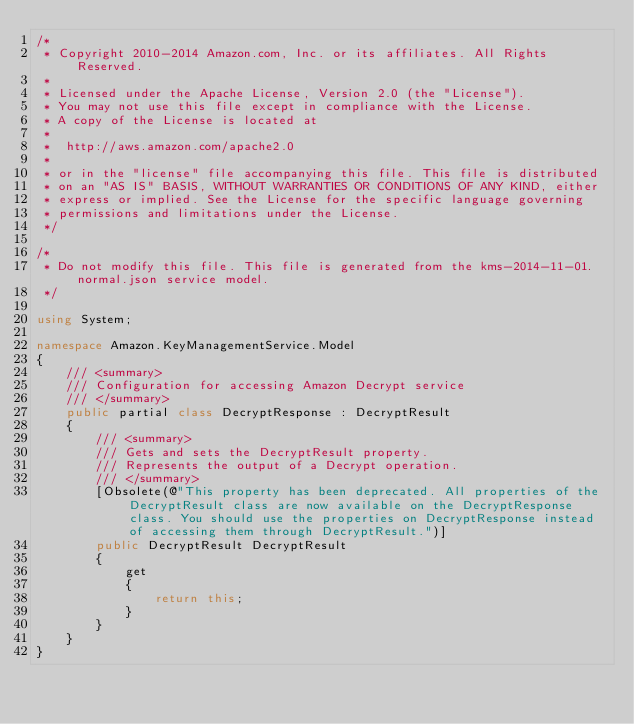<code> <loc_0><loc_0><loc_500><loc_500><_C#_>/*
 * Copyright 2010-2014 Amazon.com, Inc. or its affiliates. All Rights Reserved.
 * 
 * Licensed under the Apache License, Version 2.0 (the "License").
 * You may not use this file except in compliance with the License.
 * A copy of the License is located at
 * 
 *  http://aws.amazon.com/apache2.0
 * 
 * or in the "license" file accompanying this file. This file is distributed
 * on an "AS IS" BASIS, WITHOUT WARRANTIES OR CONDITIONS OF ANY KIND, either
 * express or implied. See the License for the specific language governing
 * permissions and limitations under the License.
 */

/*
 * Do not modify this file. This file is generated from the kms-2014-11-01.normal.json service model.
 */

using System;

namespace Amazon.KeyManagementService.Model
{
    /// <summary>
    /// Configuration for accessing Amazon Decrypt service
    /// </summary>
    public partial class DecryptResponse : DecryptResult
    {
        /// <summary>
        /// Gets and sets the DecryptResult property.
        /// Represents the output of a Decrypt operation.
        /// </summary>
        [Obsolete(@"This property has been deprecated. All properties of the DecryptResult class are now available on the DecryptResponse class. You should use the properties on DecryptResponse instead of accessing them through DecryptResult.")]
        public DecryptResult DecryptResult
        {
            get
            {
                return this;
            }
        }
    }
}</code> 